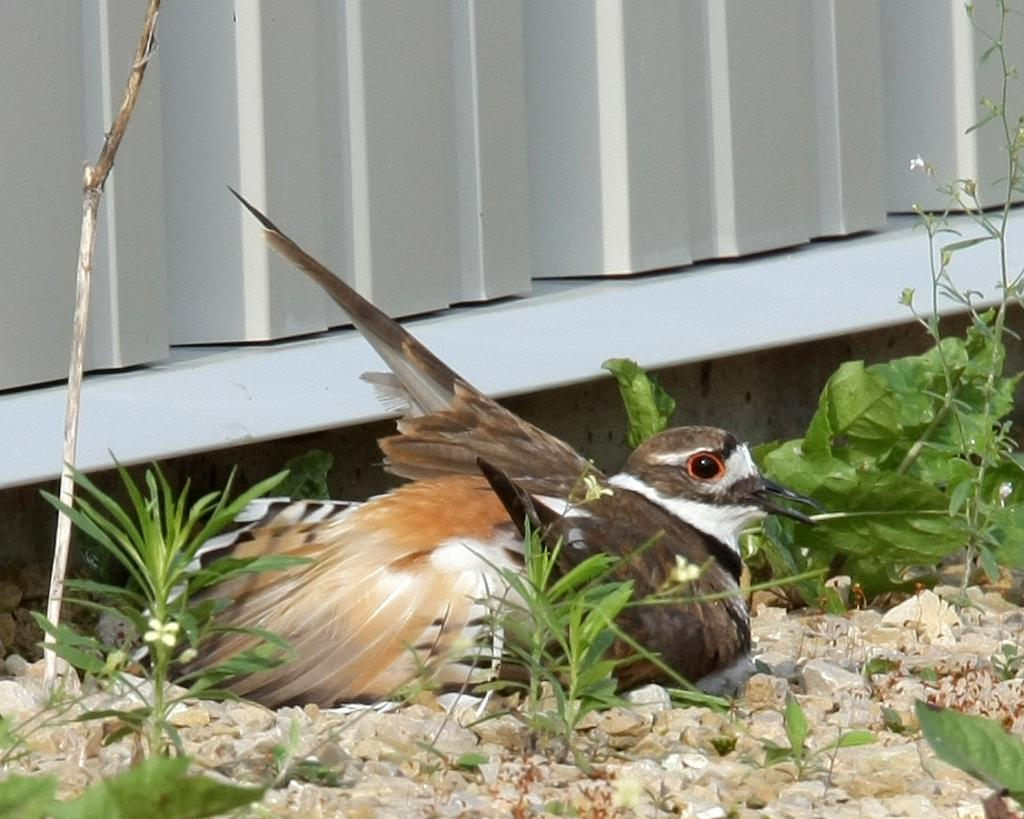What type of animal is in the image? There is a bird in the image. What colors can be seen on the bird? The bird has white, brown, and black colors. What is the bird standing on? The bird is on stones. What other elements are present in the image besides the bird? There are plants in the image. What colors are used in the background of the image? The background of the image is white and ash colored. What type of goat is sitting on the apparatus in the image? There is no goat or apparatus present in the image; it features a bird on stones with plants in the background. 